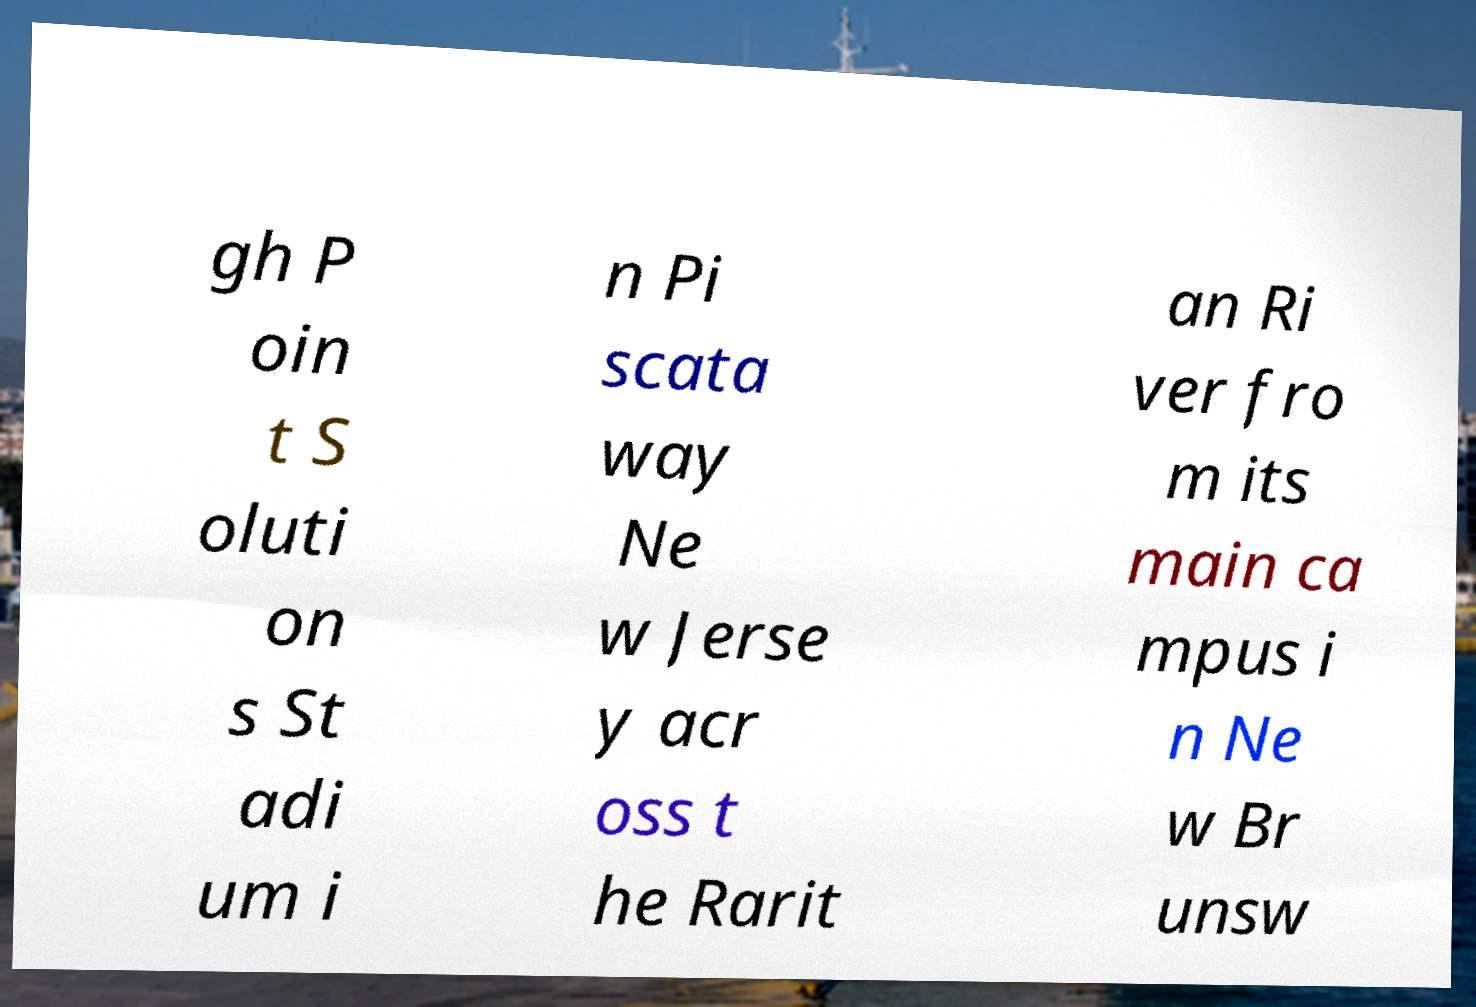Can you accurately transcribe the text from the provided image for me? gh P oin t S oluti on s St adi um i n Pi scata way Ne w Jerse y acr oss t he Rarit an Ri ver fro m its main ca mpus i n Ne w Br unsw 